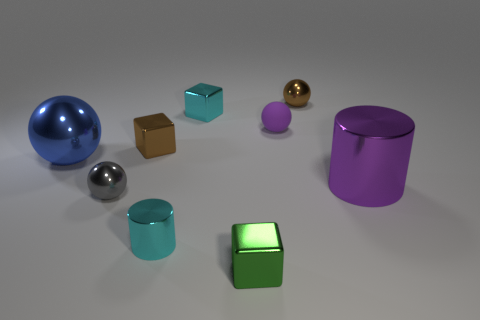Can you describe the lighting in the scene? The lighting in the scene is soft and diffuse, with shadows indicating a light source located above the objects, possibly out of the frame. This creates a calm atmosphere and gives the objects a three-dimensional appearance. Does the lighting affect the colors of the objects in any way? Yes, the lighting can slightly alter the perception of the objects' colors by creating highlights and shadows, which may make the colors appear richer and more dynamic. 